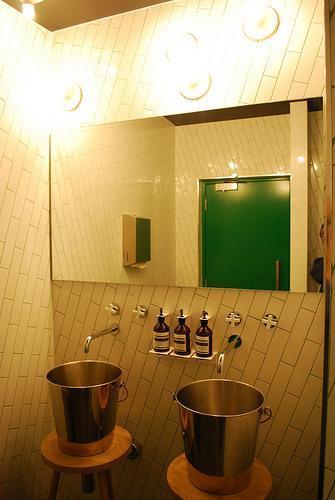How many buckets are shown?
Give a very brief answer. 2. How many bottles of soap are by the sinks?
Give a very brief answer. 3. 